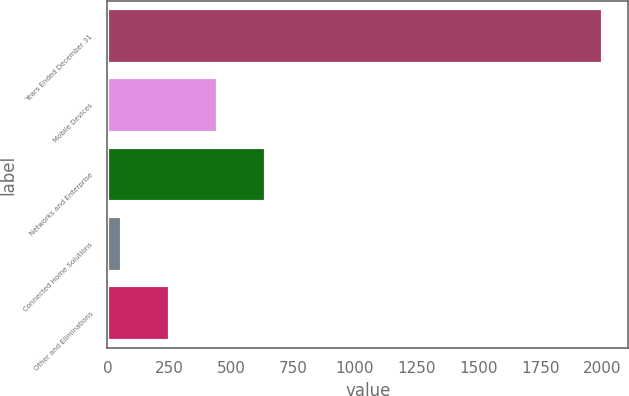<chart> <loc_0><loc_0><loc_500><loc_500><bar_chart><fcel>Years Ended December 31<fcel>Mobile Devices<fcel>Networks and Enterprise<fcel>Connected Home Solutions<fcel>Other and Eliminations<nl><fcel>2004<fcel>448<fcel>642.5<fcel>59<fcel>253.5<nl></chart> 